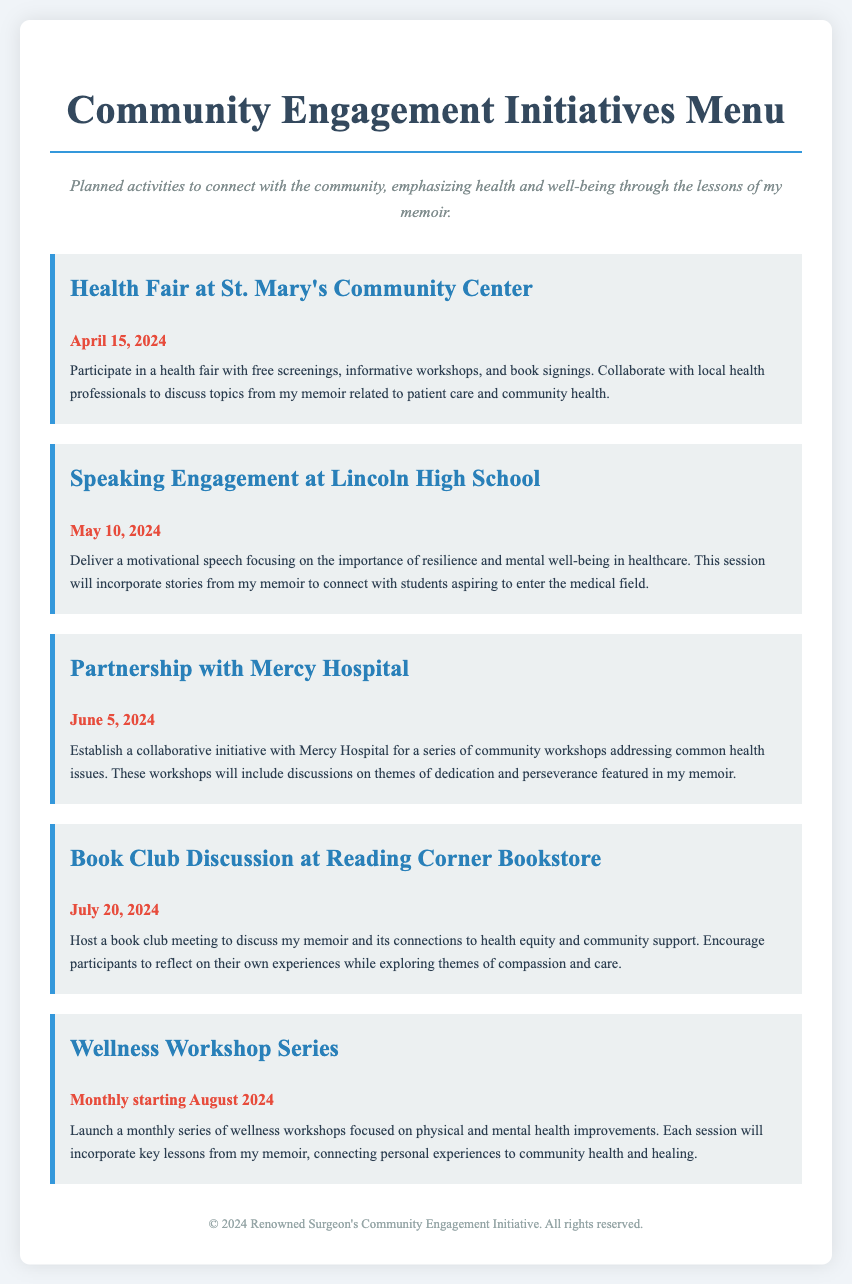What is the date of the Health Fair at St. Mary's Community Center? The date for the Health Fair is specified in the document as April 15, 2024.
Answer: April 15, 2024 What is the main focus of the speaking engagement at Lincoln High School? The document mentions that the focus will be on resilience and mental well-being in healthcare.
Answer: Resilience and mental well-being What is the name of the hospital partnering for community workshops? The document identifies Mercy Hospital as the partner for workshops.
Answer: Mercy Hospital When does the Wellness Workshop Series begin? The document indicates that the Wellness Workshop Series starts in August 2024.
Answer: August 2024 Which location is hosting a book club discussion? The document specifies Reading Corner Bookstore as the location for the book club discussion.
Answer: Reading Corner Bookstore What theme from the memoir will be discussed during the workshops with Mercy Hospital? The themes of dedication and perseverance from the memoir will be addressed in the workshops.
Answer: Dedication and perseverance What type of activities are planned in the Community Engagement Initiatives Menu? The document lists activities like health fairs, speaking engagements, and partnerships with schools.
Answer: Health fairs, speaking engagements, and partnerships How often will the Wellness Workshop Series be held? The document states that the workshops will be held monthly starting from August 2024.
Answer: Monthly 